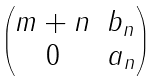Convert formula to latex. <formula><loc_0><loc_0><loc_500><loc_500>\begin{pmatrix} m + n & b _ { n } \\ 0 & a _ { n } \\ \end{pmatrix}</formula> 